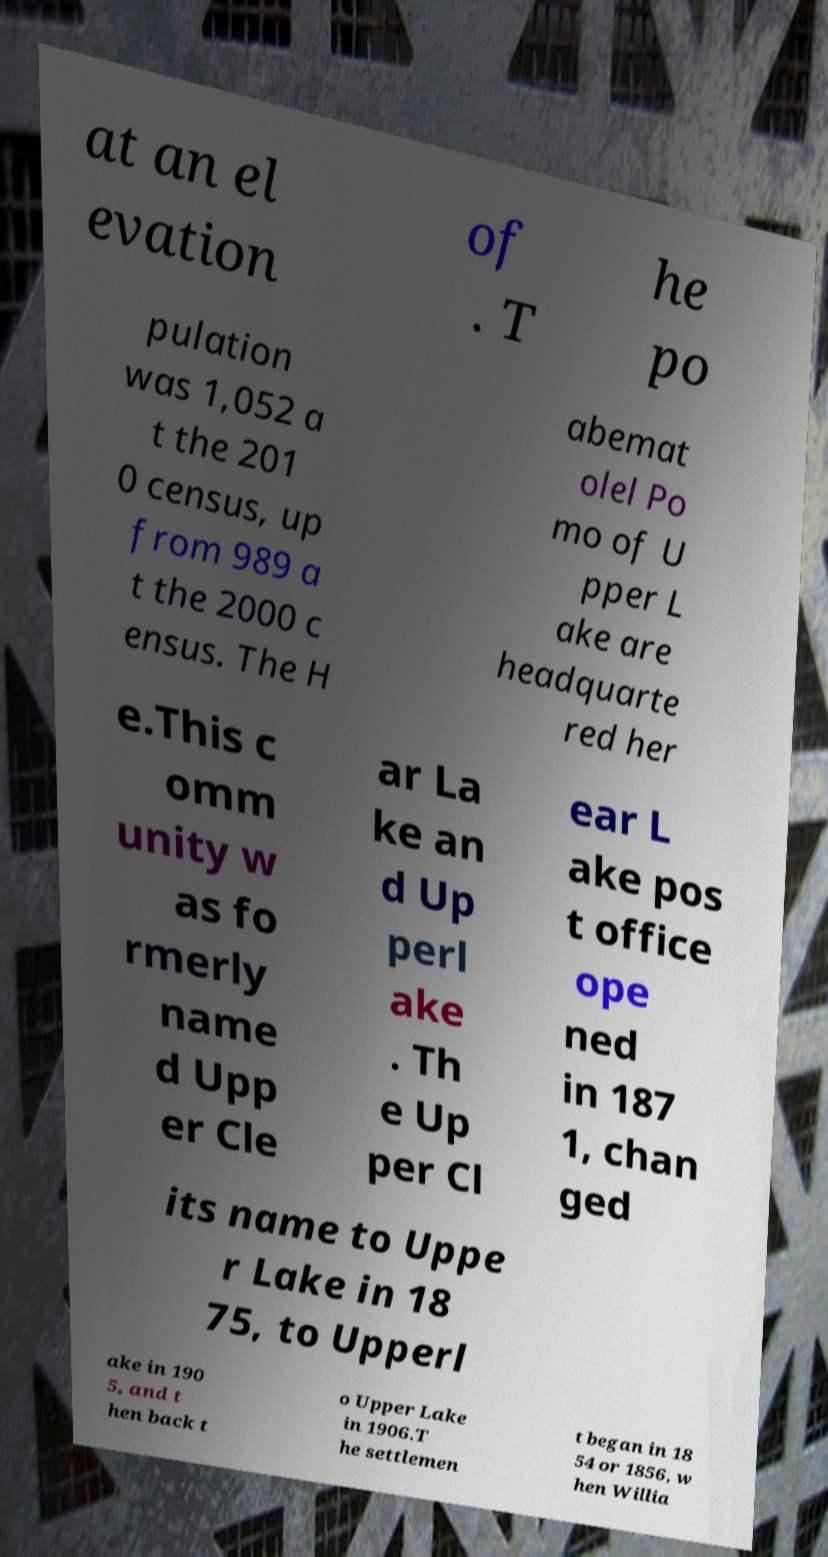Can you accurately transcribe the text from the provided image for me? at an el evation of . T he po pulation was 1,052 a t the 201 0 census, up from 989 a t the 2000 c ensus. The H abemat olel Po mo of U pper L ake are headquarte red her e.This c omm unity w as fo rmerly name d Upp er Cle ar La ke an d Up perl ake . Th e Up per Cl ear L ake pos t office ope ned in 187 1, chan ged its name to Uppe r Lake in 18 75, to Upperl ake in 190 5, and t hen back t o Upper Lake in 1906.T he settlemen t began in 18 54 or 1856, w hen Willia 